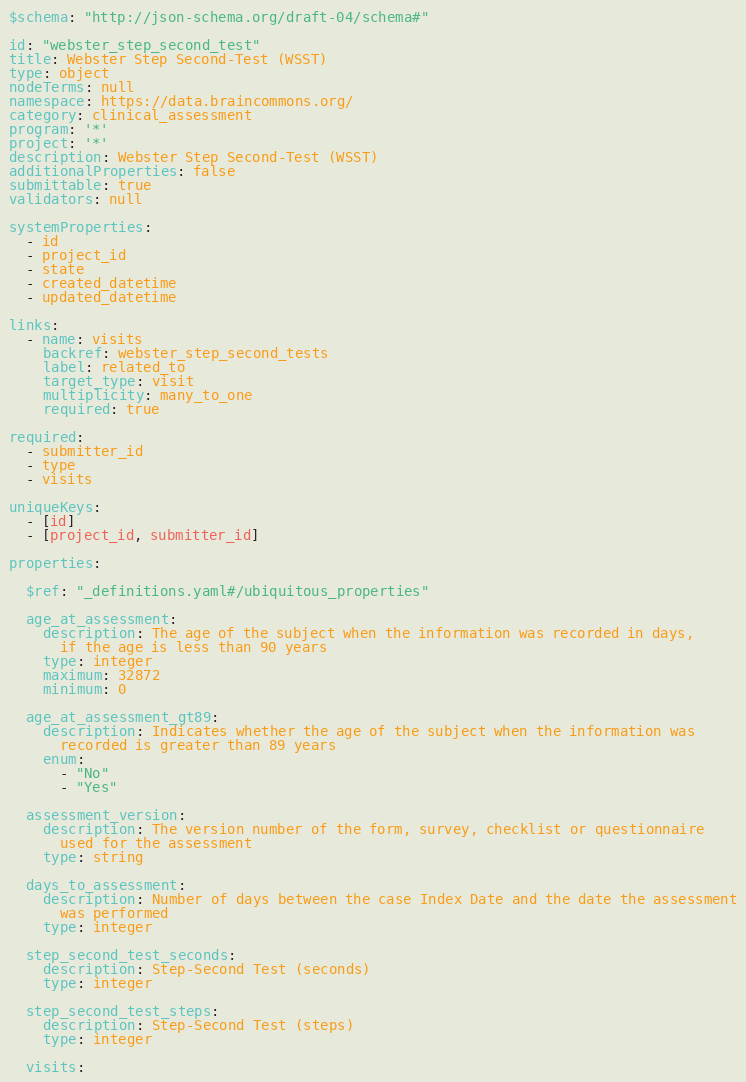<code> <loc_0><loc_0><loc_500><loc_500><_YAML_>$schema: "http://json-schema.org/draft-04/schema#"

id: "webster_step_second_test"
title: Webster Step Second-Test (WSST)
type: object
nodeTerms: null
namespace: https://data.braincommons.org/
category: clinical_assessment
program: '*'
project: '*'
description: Webster Step Second-Test (WSST)
additionalProperties: false
submittable: true
validators: null

systemProperties:
  - id
  - project_id
  - state
  - created_datetime
  - updated_datetime

links:
  - name: visits
    backref: webster_step_second_tests
    label: related_to
    target_type: visit
    multiplicity: many_to_one
    required: true

required:
  - submitter_id
  - type
  - visits

uniqueKeys:
  - [id]
  - [project_id, submitter_id]

properties:

  $ref: "_definitions.yaml#/ubiquitous_properties"

  age_at_assessment:
    description: The age of the subject when the information was recorded in days,
      if the age is less than 90 years
    type: integer
    maximum: 32872
    minimum: 0

  age_at_assessment_gt89:
    description: Indicates whether the age of the subject when the information was
      recorded is greater than 89 years
    enum:
      - "No"
      - "Yes"

  assessment_version:
    description: The version number of the form, survey, checklist or questionnaire
      used for the assessment
    type: string

  days_to_assessment:
    description: Number of days between the case Index Date and the date the assessment
      was performed
    type: integer

  step_second_test_seconds:
    description: Step-Second Test (seconds)
    type: integer

  step_second_test_steps:
    description: Step-Second Test (steps)
    type: integer

  visits:</code> 